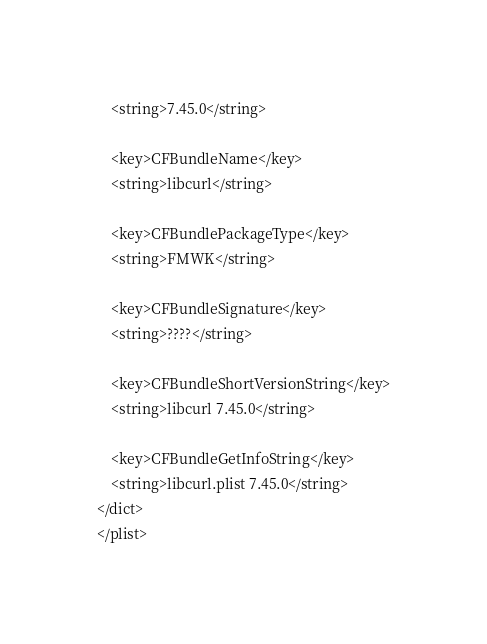<code> <loc_0><loc_0><loc_500><loc_500><_XML_>	<string>7.45.0</string>

	<key>CFBundleName</key>
	<string>libcurl</string>

	<key>CFBundlePackageType</key>
	<string>FMWK</string>

	<key>CFBundleSignature</key>
	<string>????</string>

	<key>CFBundleShortVersionString</key>
	<string>libcurl 7.45.0</string>

	<key>CFBundleGetInfoString</key>
	<string>libcurl.plist 7.45.0</string>
</dict>
</plist>
</code> 